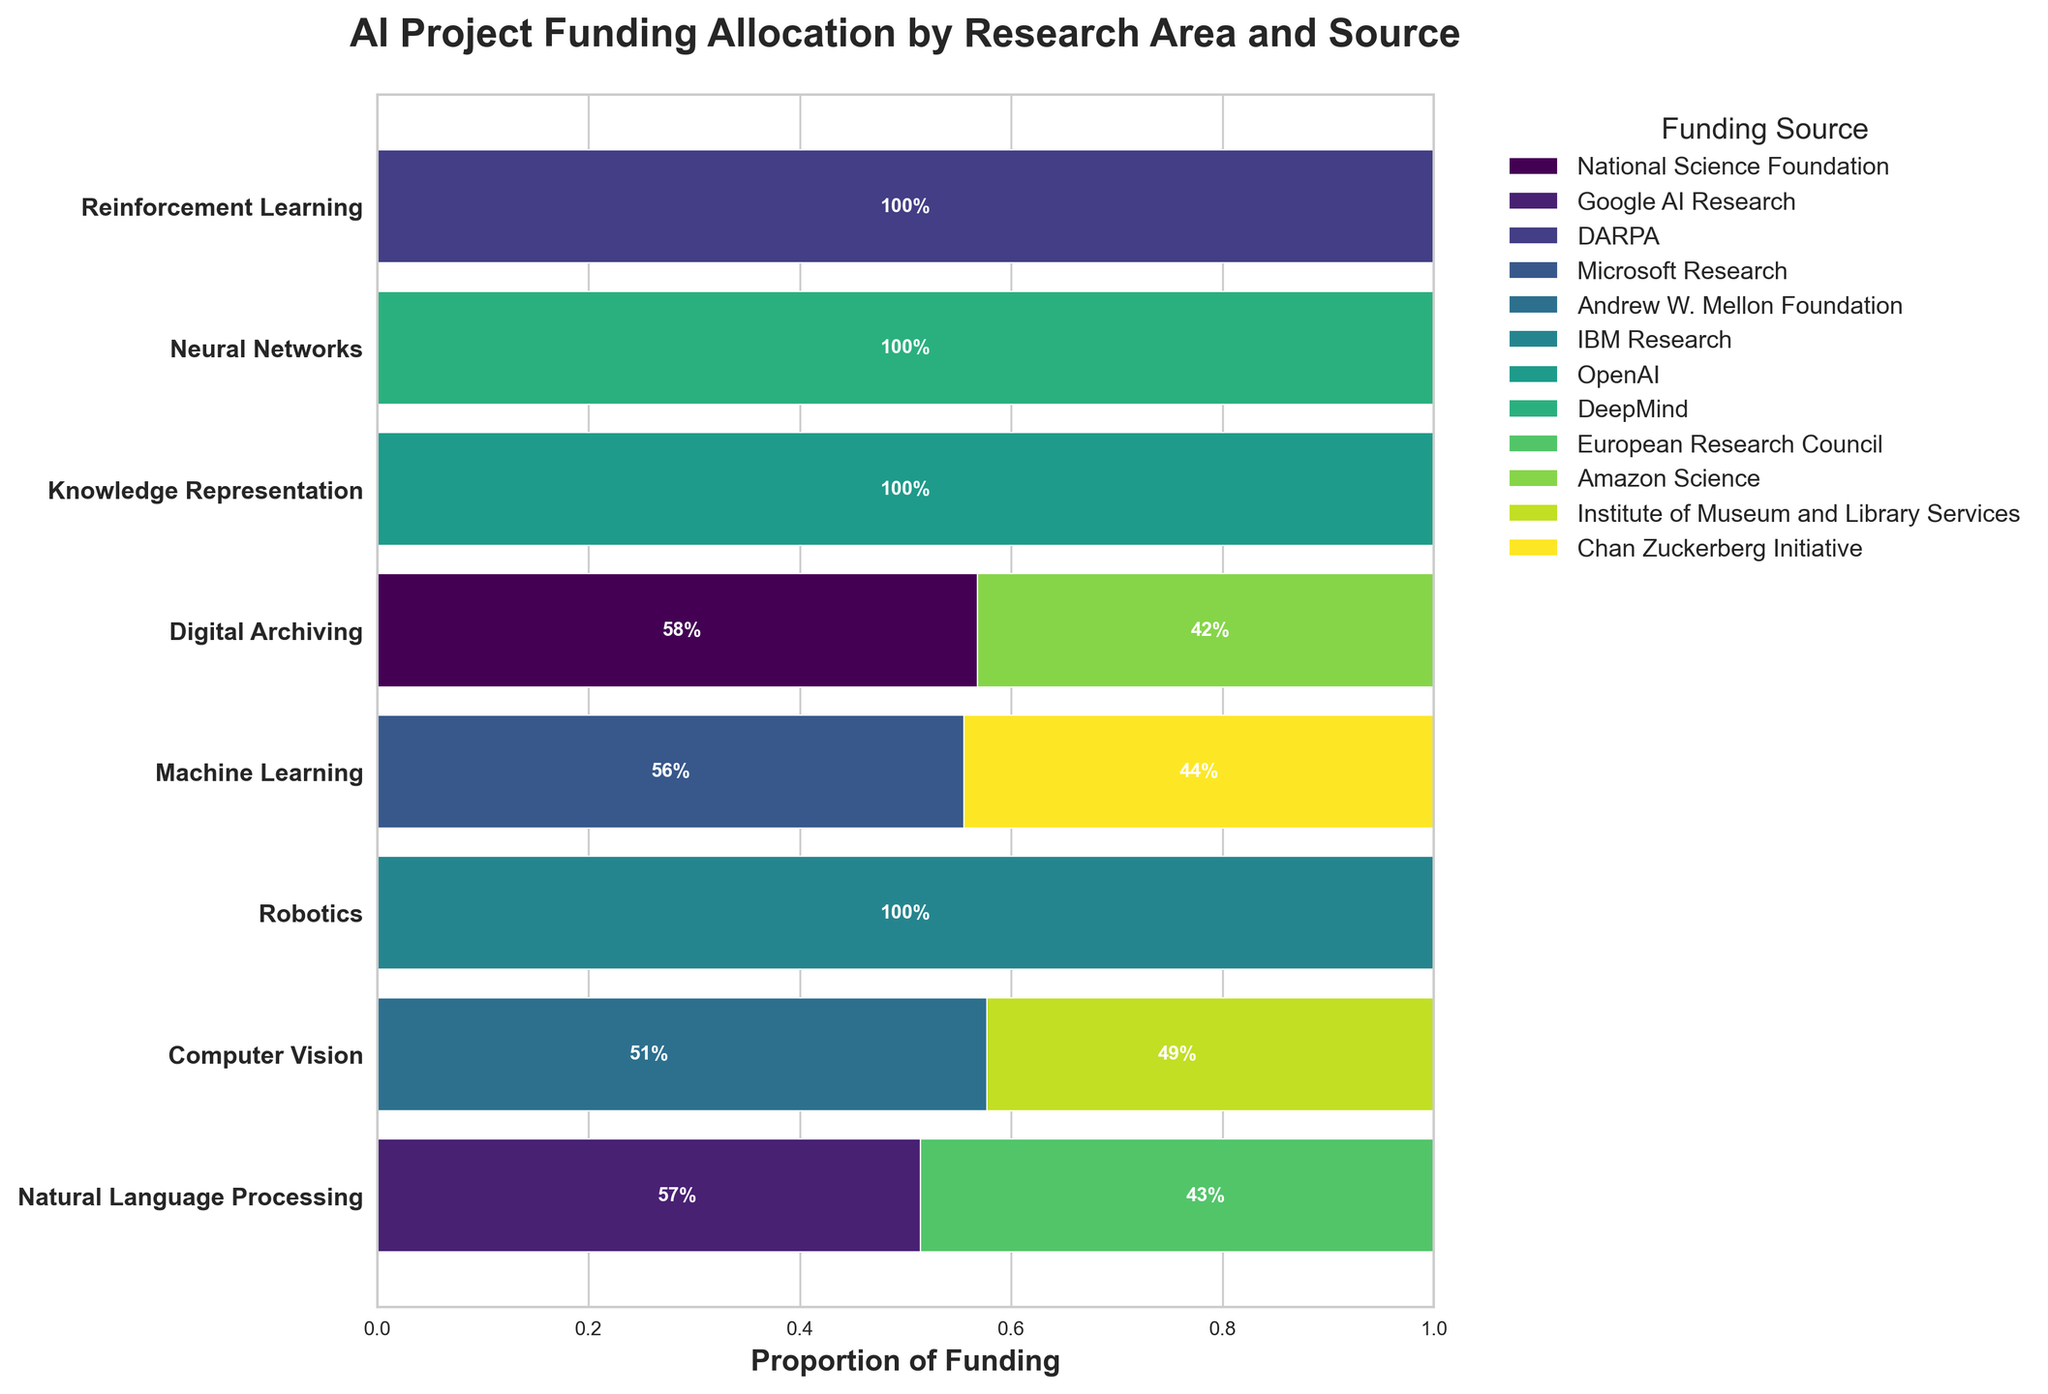Which research area has the highest proportion of funding from Microsoft Research? Look at the 'Machine Learning' bar section in the mosaic plot and find Microsoft's proportional section
Answer: Machine Learning How much funding is allocated to 'Computer Vision' from Google AI Research and the European Research Council combined? Add the funding amounts for Computer Vision from both sources:  $1,800,000 + $1,700,000
Answer: $3,500,000 Which funding source contributes the highest total proportion of funding across all research areas? Visually sum the proportional lengths of each funding source across all research areas. DARPA has the widest cumulative sections due to its significant contribution
Answer: DARPA Which research area has the smallest amount of funding from any source? Look at the bar sections by widths of proportions and check for the smallest presence. 'Knowledge Representation' has the least from IBM Research
Answer: Knowledge Representation Which organization has funded 'Reinforcement Learning'? Identify the color section associated with Reinforcement Learning and then check its legend indication for identifying the funding source
Answer: DeepMind What is the difference in the proportion of funding from OpenAI between 'Neural Networks' and 'Knowledge Representation'? Calculate the proportional difference between OpenAI sections in 'Neural Networks' and 'Knowledge Representation'
Answer: 23.7% (28% - 4.3%) What's the title of the mosaic plot? The title is clearly mentioned at the top of the plot
Answer: AI Project Funding Allocation by Research Area and Source Which funding source for 'Digital Archiving' provides a larger proportion of funding? Compare the proportional lengths of bars in 'Digital Archiving' for each source
Answer: Andrew W. Mellon Foundation 